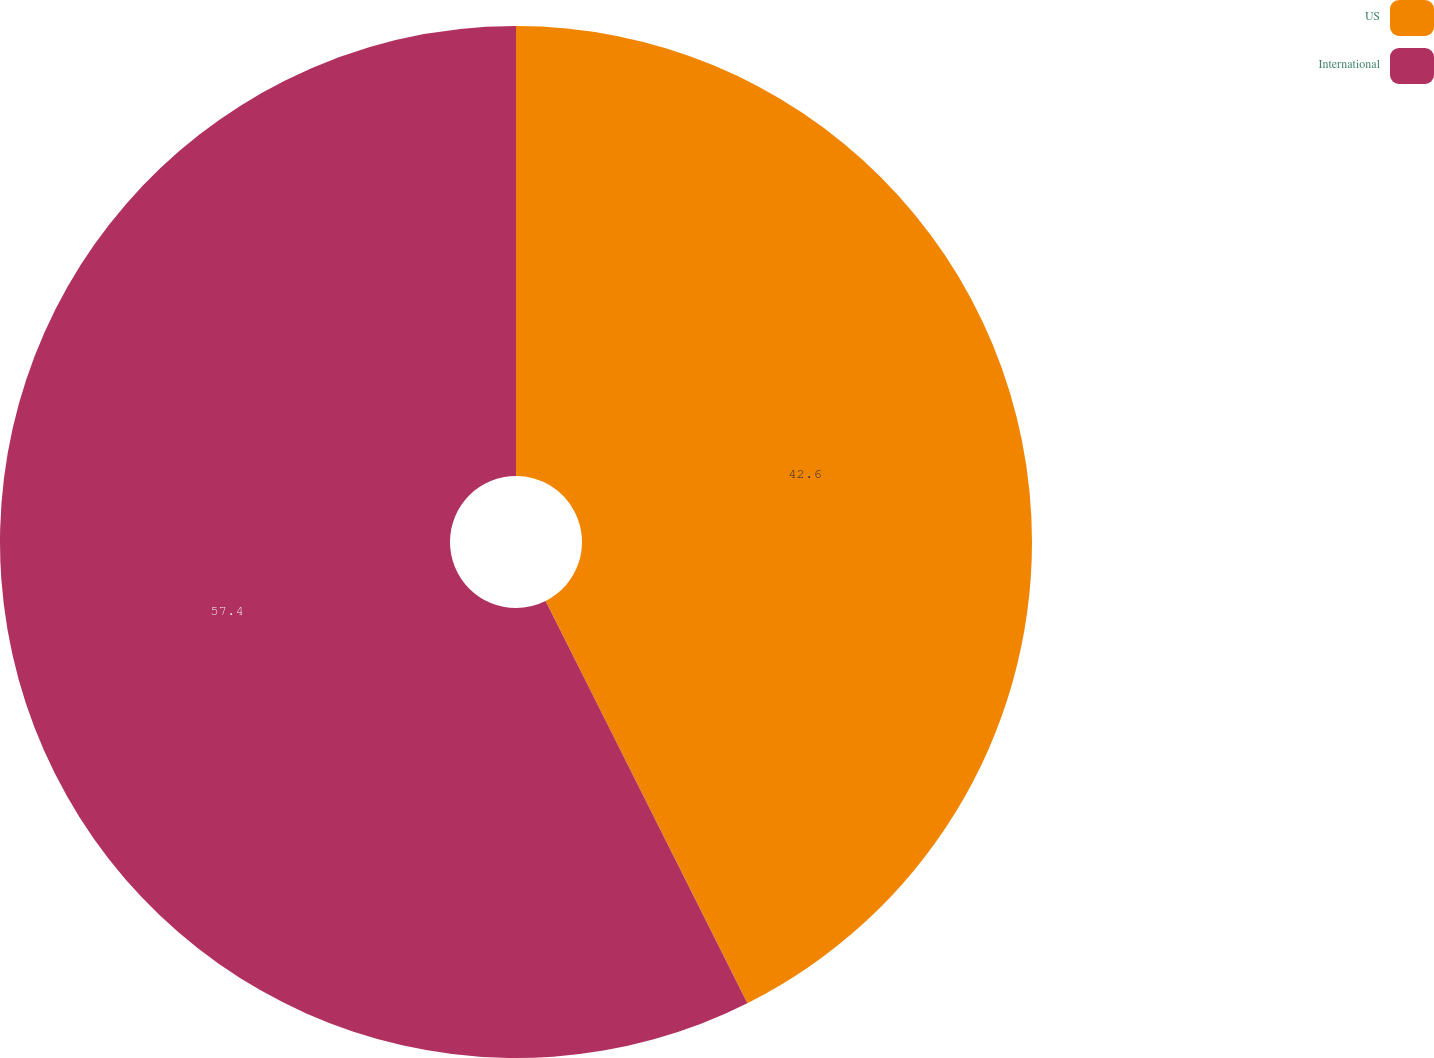Convert chart to OTSL. <chart><loc_0><loc_0><loc_500><loc_500><pie_chart><fcel>US<fcel>International<nl><fcel>42.6%<fcel>57.4%<nl></chart> 